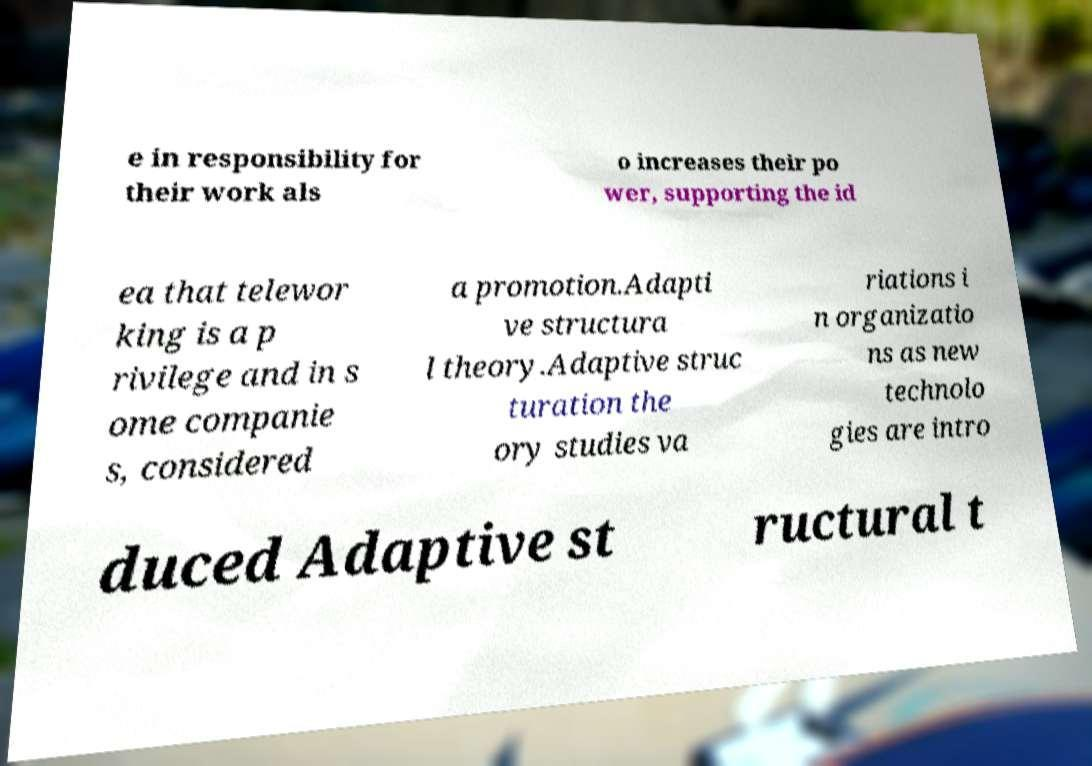There's text embedded in this image that I need extracted. Can you transcribe it verbatim? e in responsibility for their work als o increases their po wer, supporting the id ea that telewor king is a p rivilege and in s ome companie s, considered a promotion.Adapti ve structura l theory.Adaptive struc turation the ory studies va riations i n organizatio ns as new technolo gies are intro duced Adaptive st ructural t 